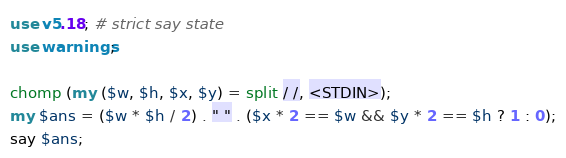<code> <loc_0><loc_0><loc_500><loc_500><_Perl_>use v5.18; # strict say state
use warnings;

chomp (my ($w, $h, $x, $y) = split / /, <STDIN>);
my $ans = ($w * $h / 2) . " " . ($x * 2 == $w && $y * 2 == $h ? 1 : 0);
say $ans;</code> 